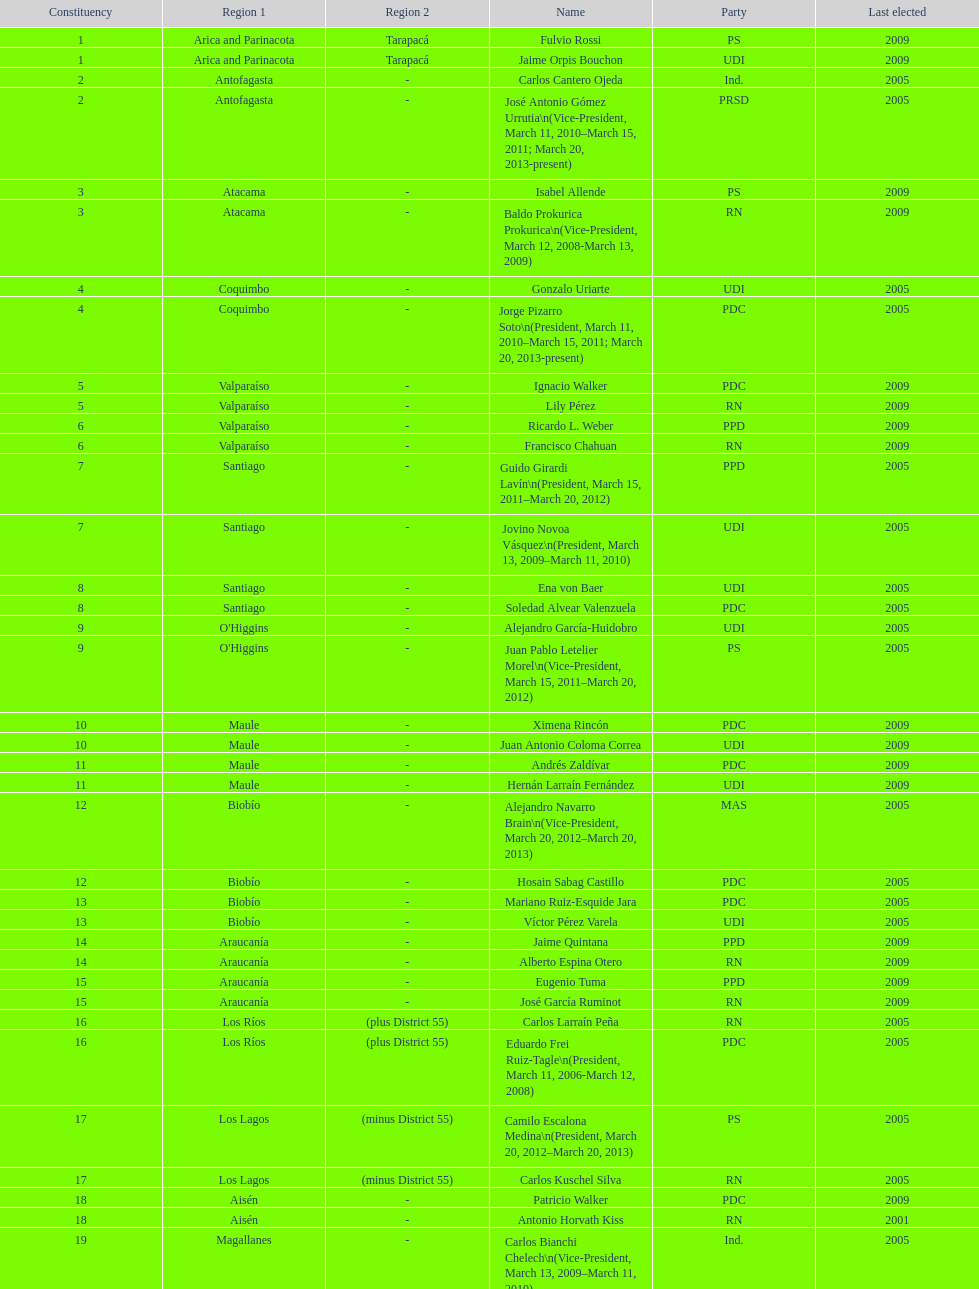Which party did jaime quintana belong to? PPD. 